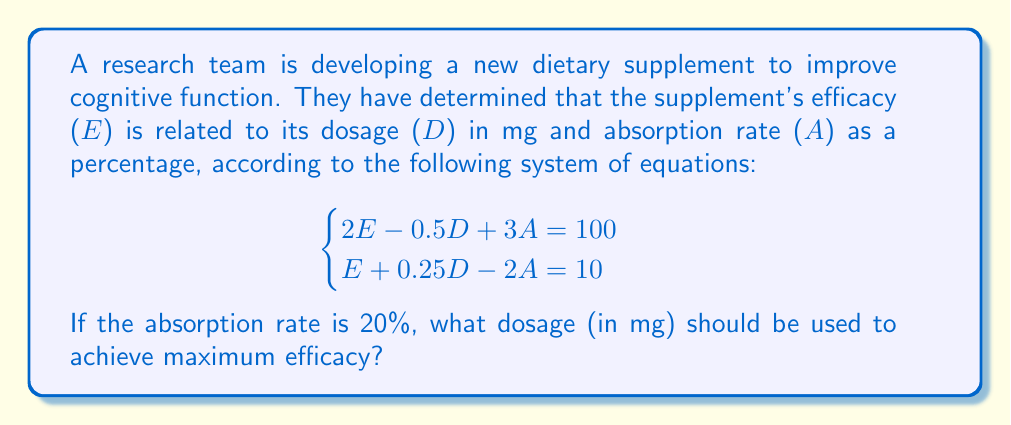Could you help me with this problem? To solve this problem, we'll follow these steps:

1) First, we'll substitute the known absorption rate (A = 20) into both equations:

   $$\begin{cases}
   2E - 0.5D + 3(20) = 100 \\
   E + 0.25D - 2(20) = 10
   \end{cases}$$

2) Simplify:

   $$\begin{cases}
   2E - 0.5D + 60 = 100 \\
   E + 0.25D - 40 = 10
   \end{cases}$$

3) Rearrange to standard form:

   $$\begin{cases}
   2E - 0.5D = 40 \\
   E + 0.25D = 50
   \end{cases}$$

4) Multiply the second equation by 2 to eliminate E when we subtract:

   $$\begin{cases}
   2E - 0.5D = 40 \\
   2E + 0.5D = 100
   \end{cases}$$

5) Subtract the first equation from the second:

   $$D = 60$$

6) To find E, substitute D = 60 into either of the original equations. Let's use the second one:

   $$E + 0.25(60) - 40 = 10$$
   $$E + 15 - 40 = 10$$
   $$E = 35$$

7) We can verify this solution satisfies both original equations:

   $$\begin{cases}
   2(35) - 0.5(60) + 3(20) = 70 - 30 + 60 = 100 \\
   35 + 0.25(60) - 2(20) = 35 + 15 - 40 = 10
   \end{cases}$$

Therefore, the dosage that should be used to achieve maximum efficacy is 60 mg.
Answer: 60 mg 